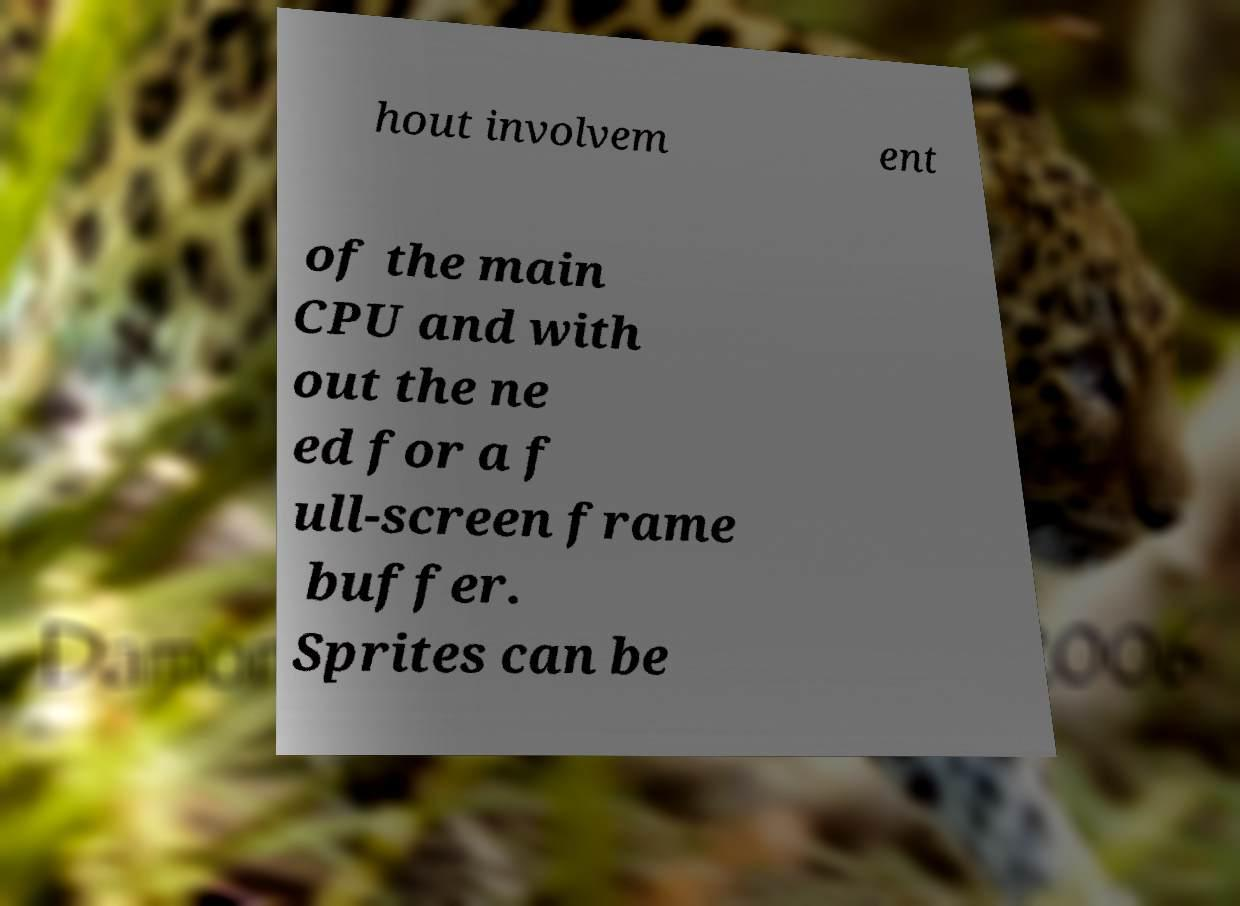Could you assist in decoding the text presented in this image and type it out clearly? hout involvem ent of the main CPU and with out the ne ed for a f ull-screen frame buffer. Sprites can be 